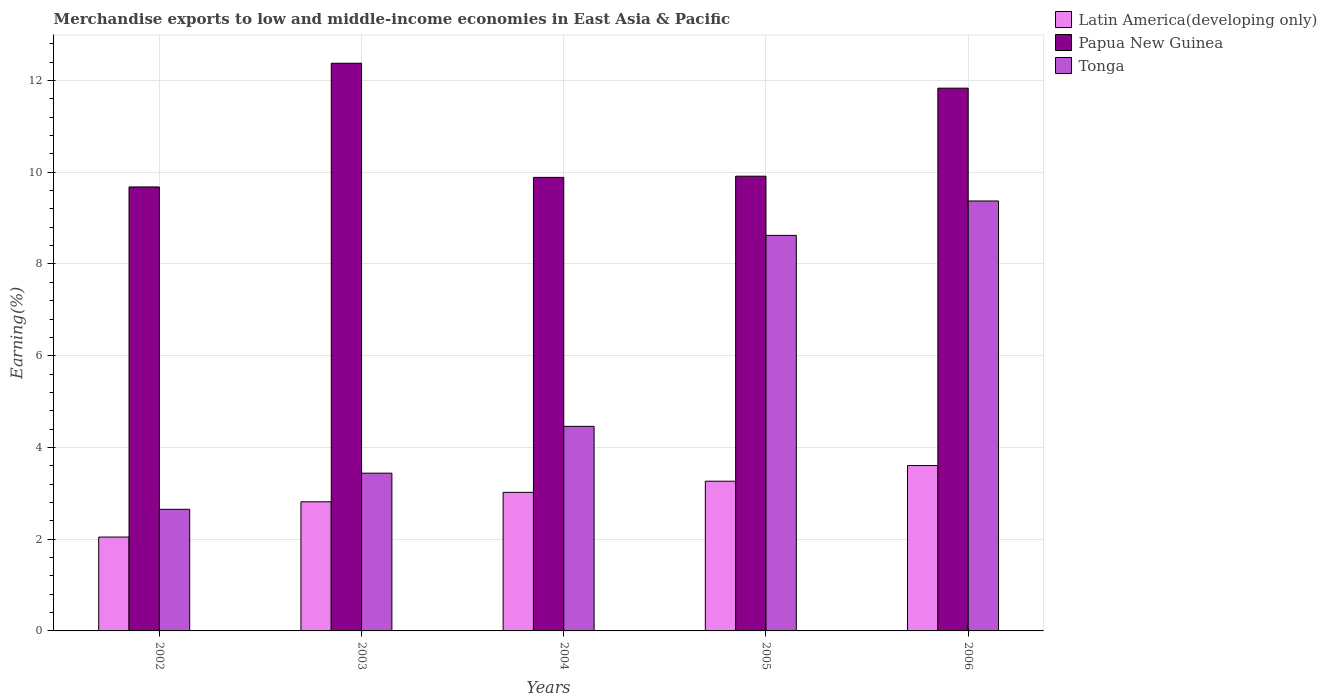How many different coloured bars are there?
Offer a very short reply. 3. How many groups of bars are there?
Offer a very short reply. 5. Are the number of bars per tick equal to the number of legend labels?
Your answer should be very brief. Yes. How many bars are there on the 2nd tick from the left?
Provide a short and direct response. 3. What is the label of the 5th group of bars from the left?
Offer a very short reply. 2006. What is the percentage of amount earned from merchandise exports in Tonga in 2002?
Make the answer very short. 2.65. Across all years, what is the maximum percentage of amount earned from merchandise exports in Latin America(developing only)?
Give a very brief answer. 3.61. Across all years, what is the minimum percentage of amount earned from merchandise exports in Tonga?
Your answer should be very brief. 2.65. What is the total percentage of amount earned from merchandise exports in Latin America(developing only) in the graph?
Offer a very short reply. 14.75. What is the difference between the percentage of amount earned from merchandise exports in Papua New Guinea in 2003 and that in 2005?
Provide a succinct answer. 2.46. What is the difference between the percentage of amount earned from merchandise exports in Latin America(developing only) in 2003 and the percentage of amount earned from merchandise exports in Tonga in 2002?
Your answer should be very brief. 0.16. What is the average percentage of amount earned from merchandise exports in Latin America(developing only) per year?
Make the answer very short. 2.95. In the year 2003, what is the difference between the percentage of amount earned from merchandise exports in Latin America(developing only) and percentage of amount earned from merchandise exports in Tonga?
Give a very brief answer. -0.62. What is the ratio of the percentage of amount earned from merchandise exports in Tonga in 2002 to that in 2006?
Give a very brief answer. 0.28. Is the difference between the percentage of amount earned from merchandise exports in Latin America(developing only) in 2003 and 2004 greater than the difference between the percentage of amount earned from merchandise exports in Tonga in 2003 and 2004?
Give a very brief answer. Yes. What is the difference between the highest and the second highest percentage of amount earned from merchandise exports in Latin America(developing only)?
Provide a succinct answer. 0.34. What is the difference between the highest and the lowest percentage of amount earned from merchandise exports in Latin America(developing only)?
Offer a terse response. 1.56. What does the 3rd bar from the left in 2004 represents?
Ensure brevity in your answer.  Tonga. What does the 3rd bar from the right in 2006 represents?
Your response must be concise. Latin America(developing only). Is it the case that in every year, the sum of the percentage of amount earned from merchandise exports in Papua New Guinea and percentage of amount earned from merchandise exports in Latin America(developing only) is greater than the percentage of amount earned from merchandise exports in Tonga?
Ensure brevity in your answer.  Yes. How many years are there in the graph?
Ensure brevity in your answer.  5. Are the values on the major ticks of Y-axis written in scientific E-notation?
Your answer should be very brief. No. Does the graph contain any zero values?
Offer a terse response. No. What is the title of the graph?
Offer a terse response. Merchandise exports to low and middle-income economies in East Asia & Pacific. Does "Costa Rica" appear as one of the legend labels in the graph?
Make the answer very short. No. What is the label or title of the Y-axis?
Ensure brevity in your answer.  Earning(%). What is the Earning(%) of Latin America(developing only) in 2002?
Your answer should be very brief. 2.05. What is the Earning(%) of Papua New Guinea in 2002?
Your response must be concise. 9.68. What is the Earning(%) in Tonga in 2002?
Provide a succinct answer. 2.65. What is the Earning(%) in Latin America(developing only) in 2003?
Make the answer very short. 2.82. What is the Earning(%) in Papua New Guinea in 2003?
Make the answer very short. 12.38. What is the Earning(%) of Tonga in 2003?
Your response must be concise. 3.44. What is the Earning(%) of Latin America(developing only) in 2004?
Provide a succinct answer. 3.02. What is the Earning(%) of Papua New Guinea in 2004?
Your answer should be compact. 9.89. What is the Earning(%) in Tonga in 2004?
Your response must be concise. 4.46. What is the Earning(%) in Latin America(developing only) in 2005?
Your answer should be very brief. 3.26. What is the Earning(%) in Papua New Guinea in 2005?
Provide a succinct answer. 9.91. What is the Earning(%) in Tonga in 2005?
Make the answer very short. 8.62. What is the Earning(%) in Latin America(developing only) in 2006?
Provide a short and direct response. 3.61. What is the Earning(%) of Papua New Guinea in 2006?
Provide a succinct answer. 11.83. What is the Earning(%) of Tonga in 2006?
Provide a succinct answer. 9.37. Across all years, what is the maximum Earning(%) of Latin America(developing only)?
Offer a terse response. 3.61. Across all years, what is the maximum Earning(%) of Papua New Guinea?
Your answer should be compact. 12.38. Across all years, what is the maximum Earning(%) of Tonga?
Provide a short and direct response. 9.37. Across all years, what is the minimum Earning(%) of Latin America(developing only)?
Provide a succinct answer. 2.05. Across all years, what is the minimum Earning(%) of Papua New Guinea?
Provide a short and direct response. 9.68. Across all years, what is the minimum Earning(%) in Tonga?
Give a very brief answer. 2.65. What is the total Earning(%) of Latin America(developing only) in the graph?
Make the answer very short. 14.75. What is the total Earning(%) of Papua New Guinea in the graph?
Ensure brevity in your answer.  53.69. What is the total Earning(%) in Tonga in the graph?
Offer a very short reply. 28.55. What is the difference between the Earning(%) in Latin America(developing only) in 2002 and that in 2003?
Provide a succinct answer. -0.77. What is the difference between the Earning(%) in Papua New Guinea in 2002 and that in 2003?
Your answer should be very brief. -2.7. What is the difference between the Earning(%) in Tonga in 2002 and that in 2003?
Your response must be concise. -0.79. What is the difference between the Earning(%) of Latin America(developing only) in 2002 and that in 2004?
Offer a terse response. -0.98. What is the difference between the Earning(%) of Papua New Guinea in 2002 and that in 2004?
Your response must be concise. -0.21. What is the difference between the Earning(%) of Tonga in 2002 and that in 2004?
Your answer should be very brief. -1.81. What is the difference between the Earning(%) in Latin America(developing only) in 2002 and that in 2005?
Provide a succinct answer. -1.22. What is the difference between the Earning(%) of Papua New Guinea in 2002 and that in 2005?
Offer a terse response. -0.23. What is the difference between the Earning(%) in Tonga in 2002 and that in 2005?
Ensure brevity in your answer.  -5.97. What is the difference between the Earning(%) in Latin America(developing only) in 2002 and that in 2006?
Ensure brevity in your answer.  -1.56. What is the difference between the Earning(%) of Papua New Guinea in 2002 and that in 2006?
Offer a terse response. -2.15. What is the difference between the Earning(%) of Tonga in 2002 and that in 2006?
Your response must be concise. -6.72. What is the difference between the Earning(%) of Latin America(developing only) in 2003 and that in 2004?
Give a very brief answer. -0.21. What is the difference between the Earning(%) in Papua New Guinea in 2003 and that in 2004?
Offer a terse response. 2.49. What is the difference between the Earning(%) of Tonga in 2003 and that in 2004?
Your answer should be compact. -1.02. What is the difference between the Earning(%) of Latin America(developing only) in 2003 and that in 2005?
Provide a succinct answer. -0.45. What is the difference between the Earning(%) of Papua New Guinea in 2003 and that in 2005?
Offer a very short reply. 2.46. What is the difference between the Earning(%) of Tonga in 2003 and that in 2005?
Your response must be concise. -5.18. What is the difference between the Earning(%) in Latin America(developing only) in 2003 and that in 2006?
Keep it short and to the point. -0.79. What is the difference between the Earning(%) in Papua New Guinea in 2003 and that in 2006?
Your answer should be very brief. 0.54. What is the difference between the Earning(%) in Tonga in 2003 and that in 2006?
Make the answer very short. -5.93. What is the difference between the Earning(%) of Latin America(developing only) in 2004 and that in 2005?
Keep it short and to the point. -0.24. What is the difference between the Earning(%) in Papua New Guinea in 2004 and that in 2005?
Keep it short and to the point. -0.03. What is the difference between the Earning(%) in Tonga in 2004 and that in 2005?
Keep it short and to the point. -4.16. What is the difference between the Earning(%) in Latin America(developing only) in 2004 and that in 2006?
Your response must be concise. -0.58. What is the difference between the Earning(%) in Papua New Guinea in 2004 and that in 2006?
Your answer should be very brief. -1.95. What is the difference between the Earning(%) in Tonga in 2004 and that in 2006?
Provide a succinct answer. -4.91. What is the difference between the Earning(%) of Latin America(developing only) in 2005 and that in 2006?
Offer a terse response. -0.34. What is the difference between the Earning(%) in Papua New Guinea in 2005 and that in 2006?
Your response must be concise. -1.92. What is the difference between the Earning(%) of Tonga in 2005 and that in 2006?
Provide a succinct answer. -0.75. What is the difference between the Earning(%) in Latin America(developing only) in 2002 and the Earning(%) in Papua New Guinea in 2003?
Your answer should be compact. -10.33. What is the difference between the Earning(%) in Latin America(developing only) in 2002 and the Earning(%) in Tonga in 2003?
Your response must be concise. -1.39. What is the difference between the Earning(%) of Papua New Guinea in 2002 and the Earning(%) of Tonga in 2003?
Your answer should be very brief. 6.24. What is the difference between the Earning(%) of Latin America(developing only) in 2002 and the Earning(%) of Papua New Guinea in 2004?
Make the answer very short. -7.84. What is the difference between the Earning(%) in Latin America(developing only) in 2002 and the Earning(%) in Tonga in 2004?
Keep it short and to the point. -2.41. What is the difference between the Earning(%) in Papua New Guinea in 2002 and the Earning(%) in Tonga in 2004?
Provide a succinct answer. 5.22. What is the difference between the Earning(%) of Latin America(developing only) in 2002 and the Earning(%) of Papua New Guinea in 2005?
Provide a short and direct response. -7.87. What is the difference between the Earning(%) of Latin America(developing only) in 2002 and the Earning(%) of Tonga in 2005?
Keep it short and to the point. -6.58. What is the difference between the Earning(%) of Papua New Guinea in 2002 and the Earning(%) of Tonga in 2005?
Keep it short and to the point. 1.06. What is the difference between the Earning(%) of Latin America(developing only) in 2002 and the Earning(%) of Papua New Guinea in 2006?
Provide a succinct answer. -9.79. What is the difference between the Earning(%) of Latin America(developing only) in 2002 and the Earning(%) of Tonga in 2006?
Ensure brevity in your answer.  -7.33. What is the difference between the Earning(%) in Papua New Guinea in 2002 and the Earning(%) in Tonga in 2006?
Your answer should be compact. 0.31. What is the difference between the Earning(%) in Latin America(developing only) in 2003 and the Earning(%) in Papua New Guinea in 2004?
Offer a terse response. -7.07. What is the difference between the Earning(%) in Latin America(developing only) in 2003 and the Earning(%) in Tonga in 2004?
Your response must be concise. -1.64. What is the difference between the Earning(%) of Papua New Guinea in 2003 and the Earning(%) of Tonga in 2004?
Ensure brevity in your answer.  7.92. What is the difference between the Earning(%) in Latin America(developing only) in 2003 and the Earning(%) in Papua New Guinea in 2005?
Give a very brief answer. -7.1. What is the difference between the Earning(%) in Latin America(developing only) in 2003 and the Earning(%) in Tonga in 2005?
Make the answer very short. -5.81. What is the difference between the Earning(%) of Papua New Guinea in 2003 and the Earning(%) of Tonga in 2005?
Offer a terse response. 3.75. What is the difference between the Earning(%) of Latin America(developing only) in 2003 and the Earning(%) of Papua New Guinea in 2006?
Provide a succinct answer. -9.02. What is the difference between the Earning(%) of Latin America(developing only) in 2003 and the Earning(%) of Tonga in 2006?
Your answer should be very brief. -6.56. What is the difference between the Earning(%) in Papua New Guinea in 2003 and the Earning(%) in Tonga in 2006?
Provide a succinct answer. 3. What is the difference between the Earning(%) of Latin America(developing only) in 2004 and the Earning(%) of Papua New Guinea in 2005?
Ensure brevity in your answer.  -6.89. What is the difference between the Earning(%) in Latin America(developing only) in 2004 and the Earning(%) in Tonga in 2005?
Give a very brief answer. -5.6. What is the difference between the Earning(%) in Papua New Guinea in 2004 and the Earning(%) in Tonga in 2005?
Your response must be concise. 1.26. What is the difference between the Earning(%) in Latin America(developing only) in 2004 and the Earning(%) in Papua New Guinea in 2006?
Your response must be concise. -8.81. What is the difference between the Earning(%) in Latin America(developing only) in 2004 and the Earning(%) in Tonga in 2006?
Your answer should be very brief. -6.35. What is the difference between the Earning(%) of Papua New Guinea in 2004 and the Earning(%) of Tonga in 2006?
Offer a very short reply. 0.51. What is the difference between the Earning(%) in Latin America(developing only) in 2005 and the Earning(%) in Papua New Guinea in 2006?
Your answer should be compact. -8.57. What is the difference between the Earning(%) of Latin America(developing only) in 2005 and the Earning(%) of Tonga in 2006?
Provide a succinct answer. -6.11. What is the difference between the Earning(%) of Papua New Guinea in 2005 and the Earning(%) of Tonga in 2006?
Provide a short and direct response. 0.54. What is the average Earning(%) in Latin America(developing only) per year?
Ensure brevity in your answer.  2.95. What is the average Earning(%) in Papua New Guinea per year?
Keep it short and to the point. 10.74. What is the average Earning(%) of Tonga per year?
Make the answer very short. 5.71. In the year 2002, what is the difference between the Earning(%) in Latin America(developing only) and Earning(%) in Papua New Guinea?
Your answer should be very brief. -7.63. In the year 2002, what is the difference between the Earning(%) in Latin America(developing only) and Earning(%) in Tonga?
Your answer should be very brief. -0.61. In the year 2002, what is the difference between the Earning(%) of Papua New Guinea and Earning(%) of Tonga?
Provide a short and direct response. 7.03. In the year 2003, what is the difference between the Earning(%) of Latin America(developing only) and Earning(%) of Papua New Guinea?
Provide a short and direct response. -9.56. In the year 2003, what is the difference between the Earning(%) in Latin America(developing only) and Earning(%) in Tonga?
Your answer should be very brief. -0.62. In the year 2003, what is the difference between the Earning(%) in Papua New Guinea and Earning(%) in Tonga?
Keep it short and to the point. 8.94. In the year 2004, what is the difference between the Earning(%) of Latin America(developing only) and Earning(%) of Papua New Guinea?
Your answer should be very brief. -6.87. In the year 2004, what is the difference between the Earning(%) in Latin America(developing only) and Earning(%) in Tonga?
Your answer should be very brief. -1.44. In the year 2004, what is the difference between the Earning(%) in Papua New Guinea and Earning(%) in Tonga?
Keep it short and to the point. 5.43. In the year 2005, what is the difference between the Earning(%) in Latin America(developing only) and Earning(%) in Papua New Guinea?
Your answer should be very brief. -6.65. In the year 2005, what is the difference between the Earning(%) in Latin America(developing only) and Earning(%) in Tonga?
Your response must be concise. -5.36. In the year 2005, what is the difference between the Earning(%) in Papua New Guinea and Earning(%) in Tonga?
Offer a terse response. 1.29. In the year 2006, what is the difference between the Earning(%) in Latin America(developing only) and Earning(%) in Papua New Guinea?
Make the answer very short. -8.23. In the year 2006, what is the difference between the Earning(%) in Latin America(developing only) and Earning(%) in Tonga?
Your answer should be compact. -5.77. In the year 2006, what is the difference between the Earning(%) of Papua New Guinea and Earning(%) of Tonga?
Make the answer very short. 2.46. What is the ratio of the Earning(%) in Latin America(developing only) in 2002 to that in 2003?
Your response must be concise. 0.73. What is the ratio of the Earning(%) in Papua New Guinea in 2002 to that in 2003?
Your answer should be very brief. 0.78. What is the ratio of the Earning(%) in Tonga in 2002 to that in 2003?
Provide a succinct answer. 0.77. What is the ratio of the Earning(%) in Latin America(developing only) in 2002 to that in 2004?
Your response must be concise. 0.68. What is the ratio of the Earning(%) in Papua New Guinea in 2002 to that in 2004?
Make the answer very short. 0.98. What is the ratio of the Earning(%) in Tonga in 2002 to that in 2004?
Give a very brief answer. 0.59. What is the ratio of the Earning(%) in Latin America(developing only) in 2002 to that in 2005?
Ensure brevity in your answer.  0.63. What is the ratio of the Earning(%) in Papua New Guinea in 2002 to that in 2005?
Keep it short and to the point. 0.98. What is the ratio of the Earning(%) in Tonga in 2002 to that in 2005?
Ensure brevity in your answer.  0.31. What is the ratio of the Earning(%) in Latin America(developing only) in 2002 to that in 2006?
Your answer should be compact. 0.57. What is the ratio of the Earning(%) in Papua New Guinea in 2002 to that in 2006?
Provide a succinct answer. 0.82. What is the ratio of the Earning(%) of Tonga in 2002 to that in 2006?
Provide a short and direct response. 0.28. What is the ratio of the Earning(%) of Latin America(developing only) in 2003 to that in 2004?
Ensure brevity in your answer.  0.93. What is the ratio of the Earning(%) of Papua New Guinea in 2003 to that in 2004?
Keep it short and to the point. 1.25. What is the ratio of the Earning(%) in Tonga in 2003 to that in 2004?
Your response must be concise. 0.77. What is the ratio of the Earning(%) of Latin America(developing only) in 2003 to that in 2005?
Ensure brevity in your answer.  0.86. What is the ratio of the Earning(%) in Papua New Guinea in 2003 to that in 2005?
Your answer should be very brief. 1.25. What is the ratio of the Earning(%) of Tonga in 2003 to that in 2005?
Keep it short and to the point. 0.4. What is the ratio of the Earning(%) in Latin America(developing only) in 2003 to that in 2006?
Make the answer very short. 0.78. What is the ratio of the Earning(%) in Papua New Guinea in 2003 to that in 2006?
Offer a very short reply. 1.05. What is the ratio of the Earning(%) in Tonga in 2003 to that in 2006?
Ensure brevity in your answer.  0.37. What is the ratio of the Earning(%) in Latin America(developing only) in 2004 to that in 2005?
Provide a short and direct response. 0.93. What is the ratio of the Earning(%) in Papua New Guinea in 2004 to that in 2005?
Give a very brief answer. 1. What is the ratio of the Earning(%) of Tonga in 2004 to that in 2005?
Your response must be concise. 0.52. What is the ratio of the Earning(%) of Latin America(developing only) in 2004 to that in 2006?
Give a very brief answer. 0.84. What is the ratio of the Earning(%) in Papua New Guinea in 2004 to that in 2006?
Give a very brief answer. 0.84. What is the ratio of the Earning(%) of Tonga in 2004 to that in 2006?
Your answer should be very brief. 0.48. What is the ratio of the Earning(%) of Latin America(developing only) in 2005 to that in 2006?
Ensure brevity in your answer.  0.91. What is the ratio of the Earning(%) in Papua New Guinea in 2005 to that in 2006?
Your answer should be very brief. 0.84. What is the difference between the highest and the second highest Earning(%) of Latin America(developing only)?
Keep it short and to the point. 0.34. What is the difference between the highest and the second highest Earning(%) of Papua New Guinea?
Make the answer very short. 0.54. What is the difference between the highest and the second highest Earning(%) in Tonga?
Give a very brief answer. 0.75. What is the difference between the highest and the lowest Earning(%) of Latin America(developing only)?
Ensure brevity in your answer.  1.56. What is the difference between the highest and the lowest Earning(%) in Papua New Guinea?
Provide a succinct answer. 2.7. What is the difference between the highest and the lowest Earning(%) in Tonga?
Offer a very short reply. 6.72. 